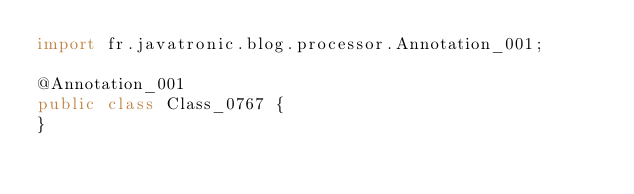<code> <loc_0><loc_0><loc_500><loc_500><_Java_>import fr.javatronic.blog.processor.Annotation_001;

@Annotation_001
public class Class_0767 {
}
</code> 